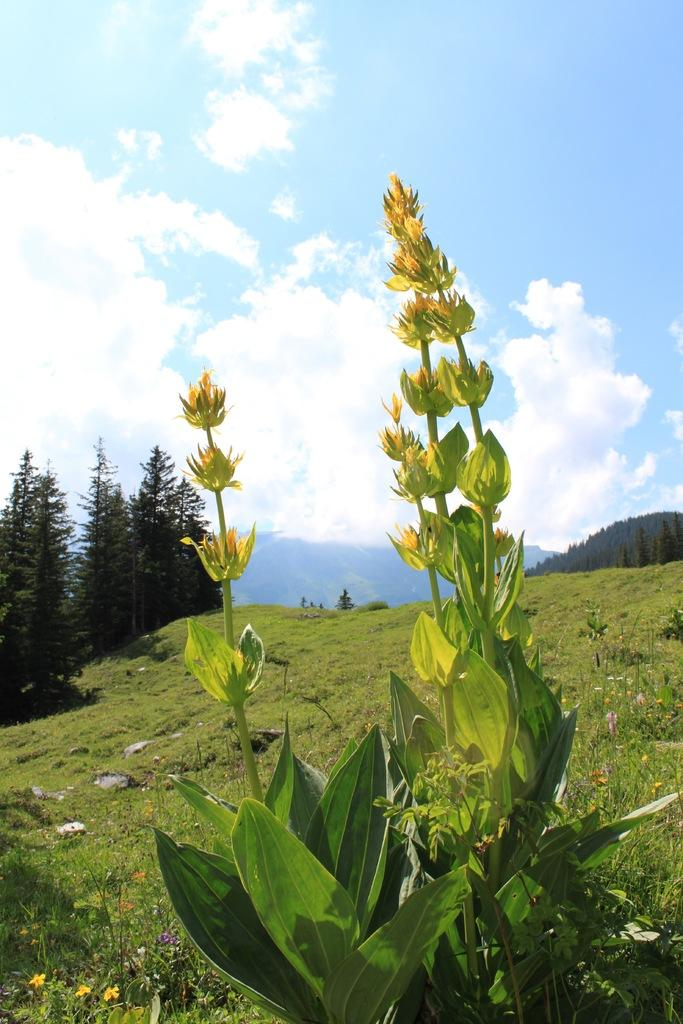What type of vegetation can be seen in the image? There are plants, grass, and trees visible in the image. What is the terrain like in the image? The image features hills in the background. What can be seen in the sky in the image? The sky is visible in the background of the image. What type of bread is being used to measure the distance between the trees in the image? There is no bread present in the image, and no measuring is taking place. 